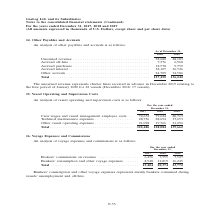According to Gaslog's financial document, What does unearned revenue represent for 2019? The unearned revenue represents charter hires received in advance in December 2019 relating to the hire period of January 2020 for 22 vessels. The document states: "The unearned revenue represents charter hires received in advance in December 2019 relating to the hire period of January 2020 for 22 vessels (Decembe..." Also, In which years was the other payables and accruals recorded for? The document shows two values: 2018 and 2019. From the document: ") For the years ended December 31, 2017, 2018 and 2019 (All amounts expressed in thousands of U.S. Dollars, except share and per share data) Continued..." Also, How many vessels were hired in 2018? According to the financial document, 17 vessels. The relevant text states: "od of January 2020 for 22 vessels (December 2018: 17 vessels)...." Additionally, In which year was the accrued interest higher? According to the financial document, 2018. The relevant text states: "Continued) For the years ended December 31, 2017, 2018 and 2019 (All amounts expressed in thousands of U.S. Dollars, except share and per share data)..." Also, can you calculate: What was the change in accrued purchases from 2018 to 2019? Based on the calculation: 9,759 - 18,578 , the result is -8819 (in thousands). This is based on the information: "off-hire . 7,376 6,968 Accrued purchases . 18,578 9,759 Accrued interest . 38,107 36,746 Other accruals . 24,709 34,586 ccrued off-hire . 7,376 6,968 Accrued purchases . 18,578 9,759 Accrued interest ..." The key data points involved are: 18,578, 9,759. Also, can you calculate: What was the percentage change in total payables and  accruals from 2018 to 2019? To answer this question, I need to perform calculations using the financial data. The calculation is: (136,242 - 127,450)/127,450 , which equals 6.9 (percentage). This is based on the information: "Total . 127,450 136,242 Total . 127,450 136,242..." The key data points involved are: 127,450, 136,242. 